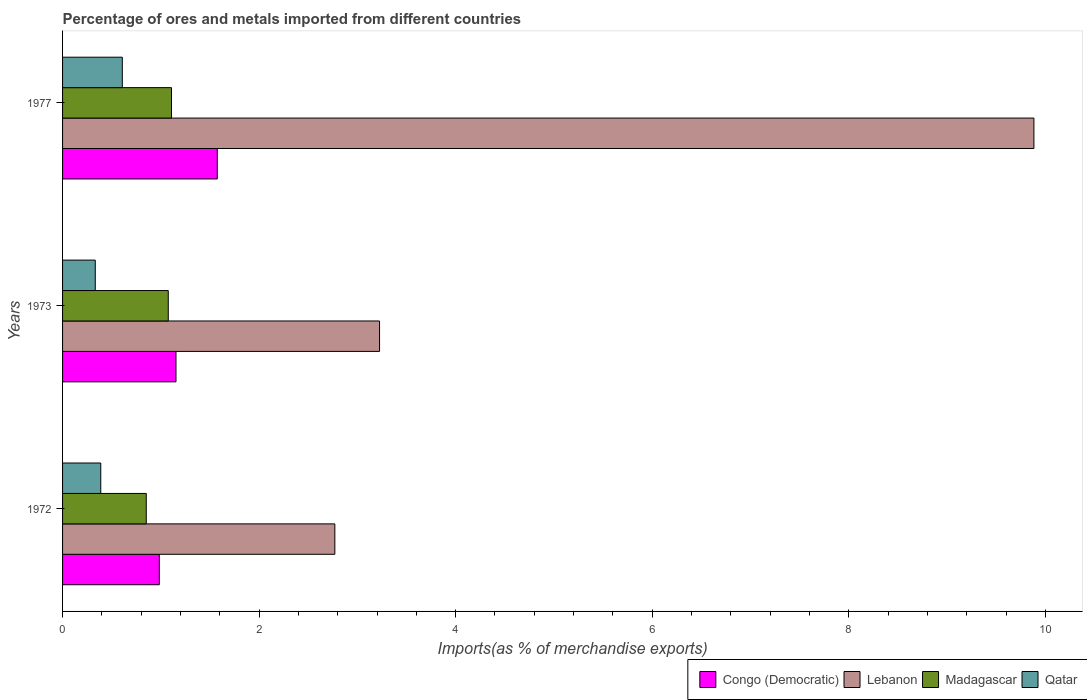Are the number of bars per tick equal to the number of legend labels?
Your answer should be compact. Yes. Are the number of bars on each tick of the Y-axis equal?
Provide a short and direct response. Yes. How many bars are there on the 1st tick from the top?
Your answer should be compact. 4. How many bars are there on the 3rd tick from the bottom?
Offer a terse response. 4. What is the percentage of imports to different countries in Qatar in 1972?
Ensure brevity in your answer.  0.39. Across all years, what is the maximum percentage of imports to different countries in Qatar?
Provide a short and direct response. 0.61. Across all years, what is the minimum percentage of imports to different countries in Congo (Democratic)?
Make the answer very short. 0.98. In which year was the percentage of imports to different countries in Lebanon maximum?
Offer a very short reply. 1977. In which year was the percentage of imports to different countries in Congo (Democratic) minimum?
Your response must be concise. 1972. What is the total percentage of imports to different countries in Congo (Democratic) in the graph?
Your answer should be compact. 3.71. What is the difference between the percentage of imports to different countries in Congo (Democratic) in 1972 and that in 1977?
Provide a short and direct response. -0.59. What is the difference between the percentage of imports to different countries in Lebanon in 1977 and the percentage of imports to different countries in Qatar in 1972?
Offer a very short reply. 9.5. What is the average percentage of imports to different countries in Lebanon per year?
Make the answer very short. 5.29. In the year 1973, what is the difference between the percentage of imports to different countries in Congo (Democratic) and percentage of imports to different countries in Lebanon?
Your response must be concise. -2.07. What is the ratio of the percentage of imports to different countries in Madagascar in 1972 to that in 1973?
Ensure brevity in your answer.  0.79. Is the percentage of imports to different countries in Qatar in 1973 less than that in 1977?
Give a very brief answer. Yes. What is the difference between the highest and the second highest percentage of imports to different countries in Congo (Democratic)?
Keep it short and to the point. 0.42. What is the difference between the highest and the lowest percentage of imports to different countries in Madagascar?
Provide a succinct answer. 0.26. In how many years, is the percentage of imports to different countries in Congo (Democratic) greater than the average percentage of imports to different countries in Congo (Democratic) taken over all years?
Your response must be concise. 1. Is the sum of the percentage of imports to different countries in Congo (Democratic) in 1973 and 1977 greater than the maximum percentage of imports to different countries in Lebanon across all years?
Your response must be concise. No. What does the 1st bar from the top in 1972 represents?
Offer a terse response. Qatar. What does the 4th bar from the bottom in 1977 represents?
Your response must be concise. Qatar. Is it the case that in every year, the sum of the percentage of imports to different countries in Lebanon and percentage of imports to different countries in Congo (Democratic) is greater than the percentage of imports to different countries in Madagascar?
Provide a succinct answer. Yes. How many bars are there?
Offer a terse response. 12. How many years are there in the graph?
Make the answer very short. 3. What is the difference between two consecutive major ticks on the X-axis?
Provide a succinct answer. 2. Are the values on the major ticks of X-axis written in scientific E-notation?
Make the answer very short. No. Does the graph contain grids?
Your response must be concise. No. What is the title of the graph?
Give a very brief answer. Percentage of ores and metals imported from different countries. Does "Mexico" appear as one of the legend labels in the graph?
Your answer should be very brief. No. What is the label or title of the X-axis?
Your answer should be very brief. Imports(as % of merchandise exports). What is the label or title of the Y-axis?
Ensure brevity in your answer.  Years. What is the Imports(as % of merchandise exports) of Congo (Democratic) in 1972?
Ensure brevity in your answer.  0.98. What is the Imports(as % of merchandise exports) in Lebanon in 1972?
Your answer should be very brief. 2.77. What is the Imports(as % of merchandise exports) of Madagascar in 1972?
Ensure brevity in your answer.  0.85. What is the Imports(as % of merchandise exports) in Qatar in 1972?
Offer a very short reply. 0.39. What is the Imports(as % of merchandise exports) of Congo (Democratic) in 1973?
Make the answer very short. 1.15. What is the Imports(as % of merchandise exports) of Lebanon in 1973?
Give a very brief answer. 3.23. What is the Imports(as % of merchandise exports) of Madagascar in 1973?
Your answer should be very brief. 1.08. What is the Imports(as % of merchandise exports) of Qatar in 1973?
Provide a short and direct response. 0.33. What is the Imports(as % of merchandise exports) of Congo (Democratic) in 1977?
Provide a succinct answer. 1.57. What is the Imports(as % of merchandise exports) of Lebanon in 1977?
Your answer should be compact. 9.88. What is the Imports(as % of merchandise exports) of Madagascar in 1977?
Ensure brevity in your answer.  1.11. What is the Imports(as % of merchandise exports) in Qatar in 1977?
Your answer should be very brief. 0.61. Across all years, what is the maximum Imports(as % of merchandise exports) of Congo (Democratic)?
Your answer should be compact. 1.57. Across all years, what is the maximum Imports(as % of merchandise exports) of Lebanon?
Make the answer very short. 9.88. Across all years, what is the maximum Imports(as % of merchandise exports) in Madagascar?
Keep it short and to the point. 1.11. Across all years, what is the maximum Imports(as % of merchandise exports) of Qatar?
Offer a terse response. 0.61. Across all years, what is the minimum Imports(as % of merchandise exports) of Congo (Democratic)?
Provide a succinct answer. 0.98. Across all years, what is the minimum Imports(as % of merchandise exports) in Lebanon?
Offer a terse response. 2.77. Across all years, what is the minimum Imports(as % of merchandise exports) of Madagascar?
Your response must be concise. 0.85. Across all years, what is the minimum Imports(as % of merchandise exports) in Qatar?
Offer a terse response. 0.33. What is the total Imports(as % of merchandise exports) in Congo (Democratic) in the graph?
Offer a very short reply. 3.71. What is the total Imports(as % of merchandise exports) of Lebanon in the graph?
Your response must be concise. 15.88. What is the total Imports(as % of merchandise exports) of Madagascar in the graph?
Ensure brevity in your answer.  3.04. What is the total Imports(as % of merchandise exports) of Qatar in the graph?
Provide a short and direct response. 1.33. What is the difference between the Imports(as % of merchandise exports) in Congo (Democratic) in 1972 and that in 1973?
Ensure brevity in your answer.  -0.17. What is the difference between the Imports(as % of merchandise exports) of Lebanon in 1972 and that in 1973?
Offer a very short reply. -0.45. What is the difference between the Imports(as % of merchandise exports) of Madagascar in 1972 and that in 1973?
Offer a terse response. -0.22. What is the difference between the Imports(as % of merchandise exports) in Qatar in 1972 and that in 1973?
Keep it short and to the point. 0.06. What is the difference between the Imports(as % of merchandise exports) of Congo (Democratic) in 1972 and that in 1977?
Ensure brevity in your answer.  -0.59. What is the difference between the Imports(as % of merchandise exports) in Lebanon in 1972 and that in 1977?
Offer a terse response. -7.11. What is the difference between the Imports(as % of merchandise exports) of Madagascar in 1972 and that in 1977?
Offer a very short reply. -0.26. What is the difference between the Imports(as % of merchandise exports) in Qatar in 1972 and that in 1977?
Keep it short and to the point. -0.22. What is the difference between the Imports(as % of merchandise exports) of Congo (Democratic) in 1973 and that in 1977?
Provide a succinct answer. -0.42. What is the difference between the Imports(as % of merchandise exports) in Lebanon in 1973 and that in 1977?
Give a very brief answer. -6.66. What is the difference between the Imports(as % of merchandise exports) in Madagascar in 1973 and that in 1977?
Your response must be concise. -0.03. What is the difference between the Imports(as % of merchandise exports) in Qatar in 1973 and that in 1977?
Make the answer very short. -0.28. What is the difference between the Imports(as % of merchandise exports) of Congo (Democratic) in 1972 and the Imports(as % of merchandise exports) of Lebanon in 1973?
Keep it short and to the point. -2.24. What is the difference between the Imports(as % of merchandise exports) of Congo (Democratic) in 1972 and the Imports(as % of merchandise exports) of Madagascar in 1973?
Your answer should be very brief. -0.09. What is the difference between the Imports(as % of merchandise exports) in Congo (Democratic) in 1972 and the Imports(as % of merchandise exports) in Qatar in 1973?
Your answer should be compact. 0.65. What is the difference between the Imports(as % of merchandise exports) of Lebanon in 1972 and the Imports(as % of merchandise exports) of Madagascar in 1973?
Keep it short and to the point. 1.7. What is the difference between the Imports(as % of merchandise exports) in Lebanon in 1972 and the Imports(as % of merchandise exports) in Qatar in 1973?
Give a very brief answer. 2.44. What is the difference between the Imports(as % of merchandise exports) of Madagascar in 1972 and the Imports(as % of merchandise exports) of Qatar in 1973?
Offer a terse response. 0.52. What is the difference between the Imports(as % of merchandise exports) in Congo (Democratic) in 1972 and the Imports(as % of merchandise exports) in Lebanon in 1977?
Make the answer very short. -8.9. What is the difference between the Imports(as % of merchandise exports) of Congo (Democratic) in 1972 and the Imports(as % of merchandise exports) of Madagascar in 1977?
Ensure brevity in your answer.  -0.12. What is the difference between the Imports(as % of merchandise exports) in Congo (Democratic) in 1972 and the Imports(as % of merchandise exports) in Qatar in 1977?
Give a very brief answer. 0.38. What is the difference between the Imports(as % of merchandise exports) of Lebanon in 1972 and the Imports(as % of merchandise exports) of Madagascar in 1977?
Offer a very short reply. 1.66. What is the difference between the Imports(as % of merchandise exports) in Lebanon in 1972 and the Imports(as % of merchandise exports) in Qatar in 1977?
Offer a terse response. 2.16. What is the difference between the Imports(as % of merchandise exports) in Madagascar in 1972 and the Imports(as % of merchandise exports) in Qatar in 1977?
Provide a short and direct response. 0.24. What is the difference between the Imports(as % of merchandise exports) of Congo (Democratic) in 1973 and the Imports(as % of merchandise exports) of Lebanon in 1977?
Make the answer very short. -8.73. What is the difference between the Imports(as % of merchandise exports) in Congo (Democratic) in 1973 and the Imports(as % of merchandise exports) in Madagascar in 1977?
Keep it short and to the point. 0.05. What is the difference between the Imports(as % of merchandise exports) in Congo (Democratic) in 1973 and the Imports(as % of merchandise exports) in Qatar in 1977?
Offer a very short reply. 0.55. What is the difference between the Imports(as % of merchandise exports) of Lebanon in 1973 and the Imports(as % of merchandise exports) of Madagascar in 1977?
Provide a short and direct response. 2.12. What is the difference between the Imports(as % of merchandise exports) in Lebanon in 1973 and the Imports(as % of merchandise exports) in Qatar in 1977?
Keep it short and to the point. 2.62. What is the difference between the Imports(as % of merchandise exports) in Madagascar in 1973 and the Imports(as % of merchandise exports) in Qatar in 1977?
Ensure brevity in your answer.  0.47. What is the average Imports(as % of merchandise exports) of Congo (Democratic) per year?
Offer a terse response. 1.24. What is the average Imports(as % of merchandise exports) of Lebanon per year?
Ensure brevity in your answer.  5.29. What is the average Imports(as % of merchandise exports) of Madagascar per year?
Ensure brevity in your answer.  1.01. What is the average Imports(as % of merchandise exports) of Qatar per year?
Offer a terse response. 0.44. In the year 1972, what is the difference between the Imports(as % of merchandise exports) of Congo (Democratic) and Imports(as % of merchandise exports) of Lebanon?
Your answer should be compact. -1.79. In the year 1972, what is the difference between the Imports(as % of merchandise exports) in Congo (Democratic) and Imports(as % of merchandise exports) in Madagascar?
Your answer should be very brief. 0.13. In the year 1972, what is the difference between the Imports(as % of merchandise exports) in Congo (Democratic) and Imports(as % of merchandise exports) in Qatar?
Your response must be concise. 0.6. In the year 1972, what is the difference between the Imports(as % of merchandise exports) in Lebanon and Imports(as % of merchandise exports) in Madagascar?
Your answer should be very brief. 1.92. In the year 1972, what is the difference between the Imports(as % of merchandise exports) of Lebanon and Imports(as % of merchandise exports) of Qatar?
Keep it short and to the point. 2.38. In the year 1972, what is the difference between the Imports(as % of merchandise exports) of Madagascar and Imports(as % of merchandise exports) of Qatar?
Provide a succinct answer. 0.46. In the year 1973, what is the difference between the Imports(as % of merchandise exports) of Congo (Democratic) and Imports(as % of merchandise exports) of Lebanon?
Ensure brevity in your answer.  -2.07. In the year 1973, what is the difference between the Imports(as % of merchandise exports) in Congo (Democratic) and Imports(as % of merchandise exports) in Madagascar?
Provide a succinct answer. 0.08. In the year 1973, what is the difference between the Imports(as % of merchandise exports) in Congo (Democratic) and Imports(as % of merchandise exports) in Qatar?
Provide a succinct answer. 0.82. In the year 1973, what is the difference between the Imports(as % of merchandise exports) of Lebanon and Imports(as % of merchandise exports) of Madagascar?
Ensure brevity in your answer.  2.15. In the year 1973, what is the difference between the Imports(as % of merchandise exports) of Lebanon and Imports(as % of merchandise exports) of Qatar?
Provide a short and direct response. 2.89. In the year 1973, what is the difference between the Imports(as % of merchandise exports) in Madagascar and Imports(as % of merchandise exports) in Qatar?
Offer a terse response. 0.74. In the year 1977, what is the difference between the Imports(as % of merchandise exports) in Congo (Democratic) and Imports(as % of merchandise exports) in Lebanon?
Provide a short and direct response. -8.31. In the year 1977, what is the difference between the Imports(as % of merchandise exports) of Congo (Democratic) and Imports(as % of merchandise exports) of Madagascar?
Your answer should be very brief. 0.47. In the year 1977, what is the difference between the Imports(as % of merchandise exports) in Congo (Democratic) and Imports(as % of merchandise exports) in Qatar?
Offer a terse response. 0.97. In the year 1977, what is the difference between the Imports(as % of merchandise exports) of Lebanon and Imports(as % of merchandise exports) of Madagascar?
Your response must be concise. 8.78. In the year 1977, what is the difference between the Imports(as % of merchandise exports) in Lebanon and Imports(as % of merchandise exports) in Qatar?
Your answer should be very brief. 9.28. In the year 1977, what is the difference between the Imports(as % of merchandise exports) in Madagascar and Imports(as % of merchandise exports) in Qatar?
Offer a terse response. 0.5. What is the ratio of the Imports(as % of merchandise exports) of Congo (Democratic) in 1972 to that in 1973?
Provide a short and direct response. 0.85. What is the ratio of the Imports(as % of merchandise exports) of Lebanon in 1972 to that in 1973?
Make the answer very short. 0.86. What is the ratio of the Imports(as % of merchandise exports) of Madagascar in 1972 to that in 1973?
Offer a very short reply. 0.79. What is the ratio of the Imports(as % of merchandise exports) of Qatar in 1972 to that in 1973?
Your answer should be very brief. 1.17. What is the ratio of the Imports(as % of merchandise exports) of Congo (Democratic) in 1972 to that in 1977?
Give a very brief answer. 0.63. What is the ratio of the Imports(as % of merchandise exports) of Lebanon in 1972 to that in 1977?
Give a very brief answer. 0.28. What is the ratio of the Imports(as % of merchandise exports) of Madagascar in 1972 to that in 1977?
Offer a terse response. 0.77. What is the ratio of the Imports(as % of merchandise exports) of Qatar in 1972 to that in 1977?
Offer a very short reply. 0.64. What is the ratio of the Imports(as % of merchandise exports) of Congo (Democratic) in 1973 to that in 1977?
Ensure brevity in your answer.  0.73. What is the ratio of the Imports(as % of merchandise exports) of Lebanon in 1973 to that in 1977?
Ensure brevity in your answer.  0.33. What is the ratio of the Imports(as % of merchandise exports) in Madagascar in 1973 to that in 1977?
Provide a succinct answer. 0.97. What is the ratio of the Imports(as % of merchandise exports) in Qatar in 1973 to that in 1977?
Your answer should be very brief. 0.55. What is the difference between the highest and the second highest Imports(as % of merchandise exports) in Congo (Democratic)?
Offer a very short reply. 0.42. What is the difference between the highest and the second highest Imports(as % of merchandise exports) of Lebanon?
Give a very brief answer. 6.66. What is the difference between the highest and the second highest Imports(as % of merchandise exports) of Madagascar?
Offer a terse response. 0.03. What is the difference between the highest and the second highest Imports(as % of merchandise exports) of Qatar?
Keep it short and to the point. 0.22. What is the difference between the highest and the lowest Imports(as % of merchandise exports) of Congo (Democratic)?
Provide a succinct answer. 0.59. What is the difference between the highest and the lowest Imports(as % of merchandise exports) of Lebanon?
Your answer should be compact. 7.11. What is the difference between the highest and the lowest Imports(as % of merchandise exports) of Madagascar?
Keep it short and to the point. 0.26. What is the difference between the highest and the lowest Imports(as % of merchandise exports) in Qatar?
Offer a very short reply. 0.28. 